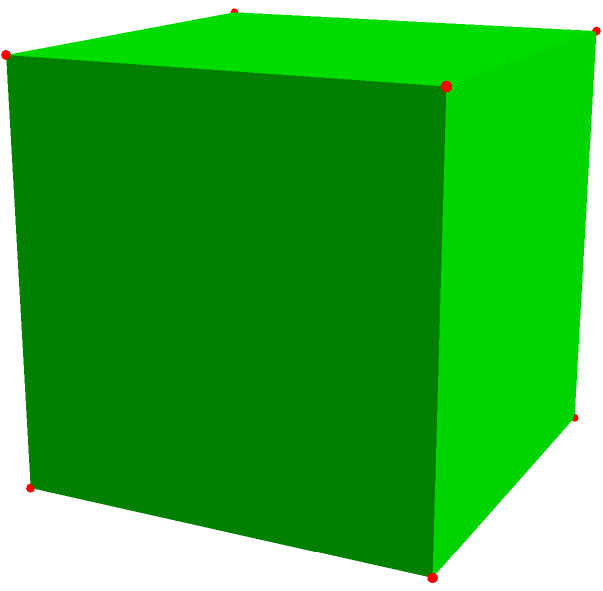In this geometric shape, which represents a regular octahedron, how many faces, edges, and vertices are there in total? Consider how this knowledge might relate to efficient resource allocation in public projects. Let's break down the properties of a regular octahedron step by step:

1. Faces:
   - Each face of an octahedron is an equilateral triangle.
   - We can count 8 triangular faces in the diagram.

2. Vertices:
   - Each corner point where edges meet is a vertex.
   - We can count 6 vertices in the diagram.

3. Edges:
   - Each line segment connecting two vertices is an edge.
   - We can count 12 edges in the diagram.

To verify these numbers, we can use Euler's formula for polyhedra:
$$ V - E + F = 2 $$
Where V is the number of vertices, E is the number of edges, and F is the number of faces.

Plugging in our values:
$$ 6 - 12 + 8 = 2 $$

This confirms that our count is correct.

Relating this to resource allocation:
Understanding geometric principles can be applied to optimize packaging, transportation, or construction projects, potentially leading to cost savings in public infrastructure projects. For example, octahedral structures might be used in architectural designs for their strength and efficiency, which could impact public spending on building projects.
Answer: 8 faces, 12 edges, 6 vertices 